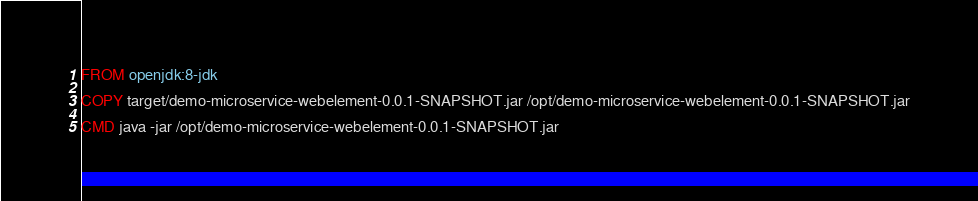Convert code to text. <code><loc_0><loc_0><loc_500><loc_500><_Dockerfile_>FROM openjdk:8-jdk

COPY target/demo-microservice-webelement-0.0.1-SNAPSHOT.jar /opt/demo-microservice-webelement-0.0.1-SNAPSHOT.jar

CMD java -jar /opt/demo-microservice-webelement-0.0.1-SNAPSHOT.jar
</code> 